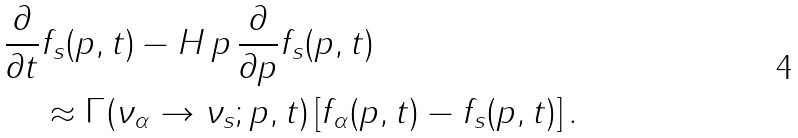Convert formula to latex. <formula><loc_0><loc_0><loc_500><loc_500>& \frac { \partial } { \partial { t } } f _ { s } ( p , t ) - H \, p \, \frac { \partial } { \partial { p } } f _ { s } ( p , t ) \\ & \quad \approx \Gamma ( \nu _ { \alpha } \rightarrow \nu _ { s } ; p , t ) \left [ f _ { \alpha } ( p , t ) - f _ { s } ( p , t ) \right ] .</formula> 